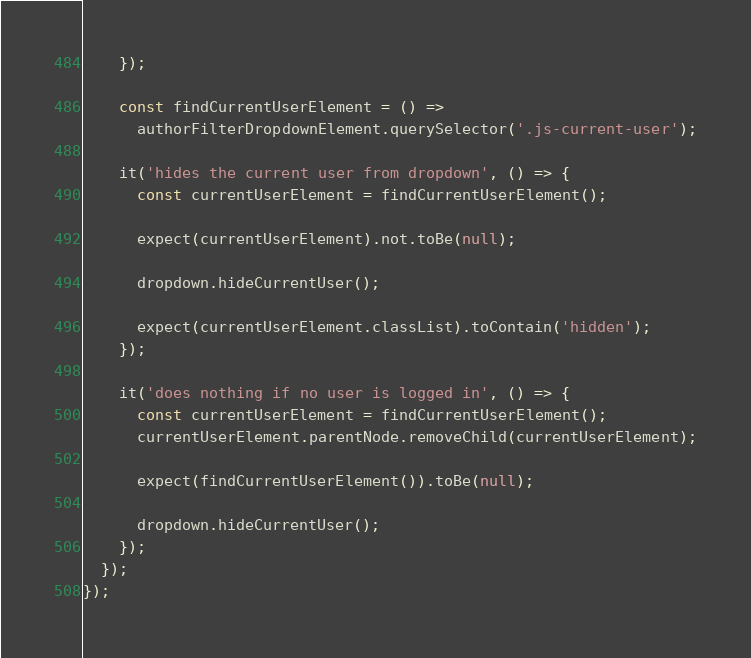Convert code to text. <code><loc_0><loc_0><loc_500><loc_500><_JavaScript_>    });

    const findCurrentUserElement = () =>
      authorFilterDropdownElement.querySelector('.js-current-user');

    it('hides the current user from dropdown', () => {
      const currentUserElement = findCurrentUserElement();

      expect(currentUserElement).not.toBe(null);

      dropdown.hideCurrentUser();

      expect(currentUserElement.classList).toContain('hidden');
    });

    it('does nothing if no user is logged in', () => {
      const currentUserElement = findCurrentUserElement();
      currentUserElement.parentNode.removeChild(currentUserElement);

      expect(findCurrentUserElement()).toBe(null);

      dropdown.hideCurrentUser();
    });
  });
});
</code> 